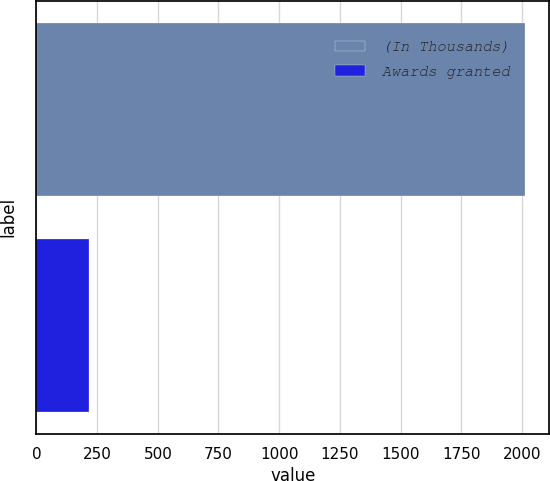Convert chart. <chart><loc_0><loc_0><loc_500><loc_500><bar_chart><fcel>(In Thousands)<fcel>Awards granted<nl><fcel>2013<fcel>215<nl></chart> 